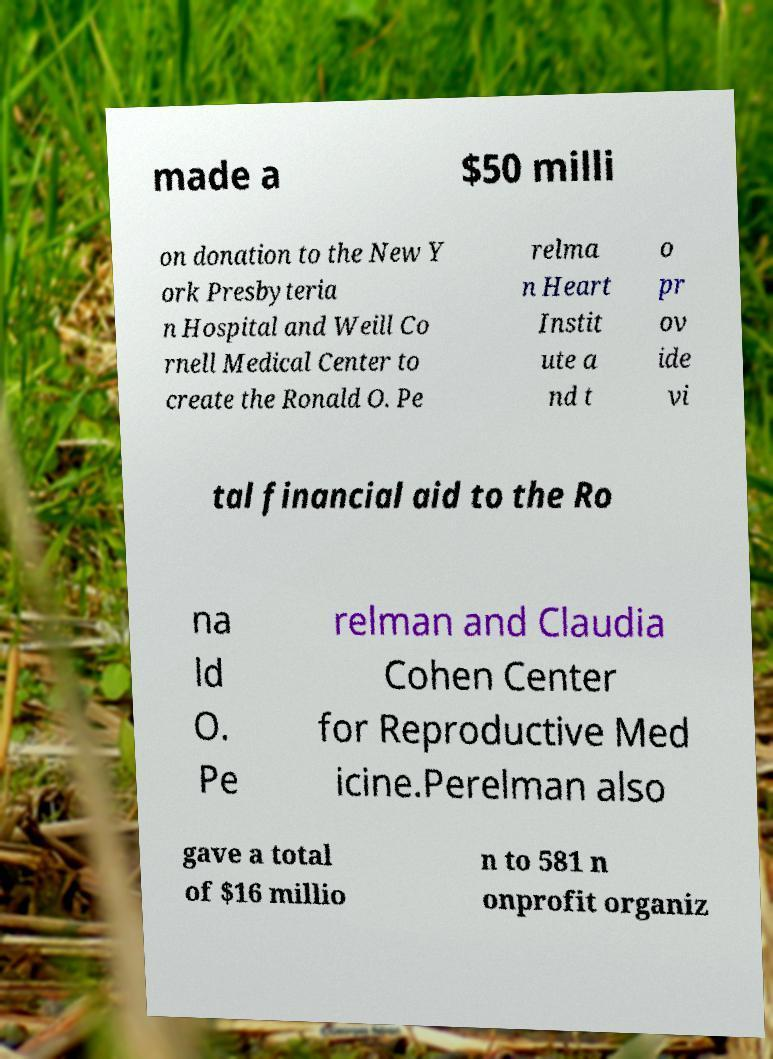Can you accurately transcribe the text from the provided image for me? made a $50 milli on donation to the New Y ork Presbyteria n Hospital and Weill Co rnell Medical Center to create the Ronald O. Pe relma n Heart Instit ute a nd t o pr ov ide vi tal financial aid to the Ro na ld O. Pe relman and Claudia Cohen Center for Reproductive Med icine.Perelman also gave a total of $16 millio n to 581 n onprofit organiz 